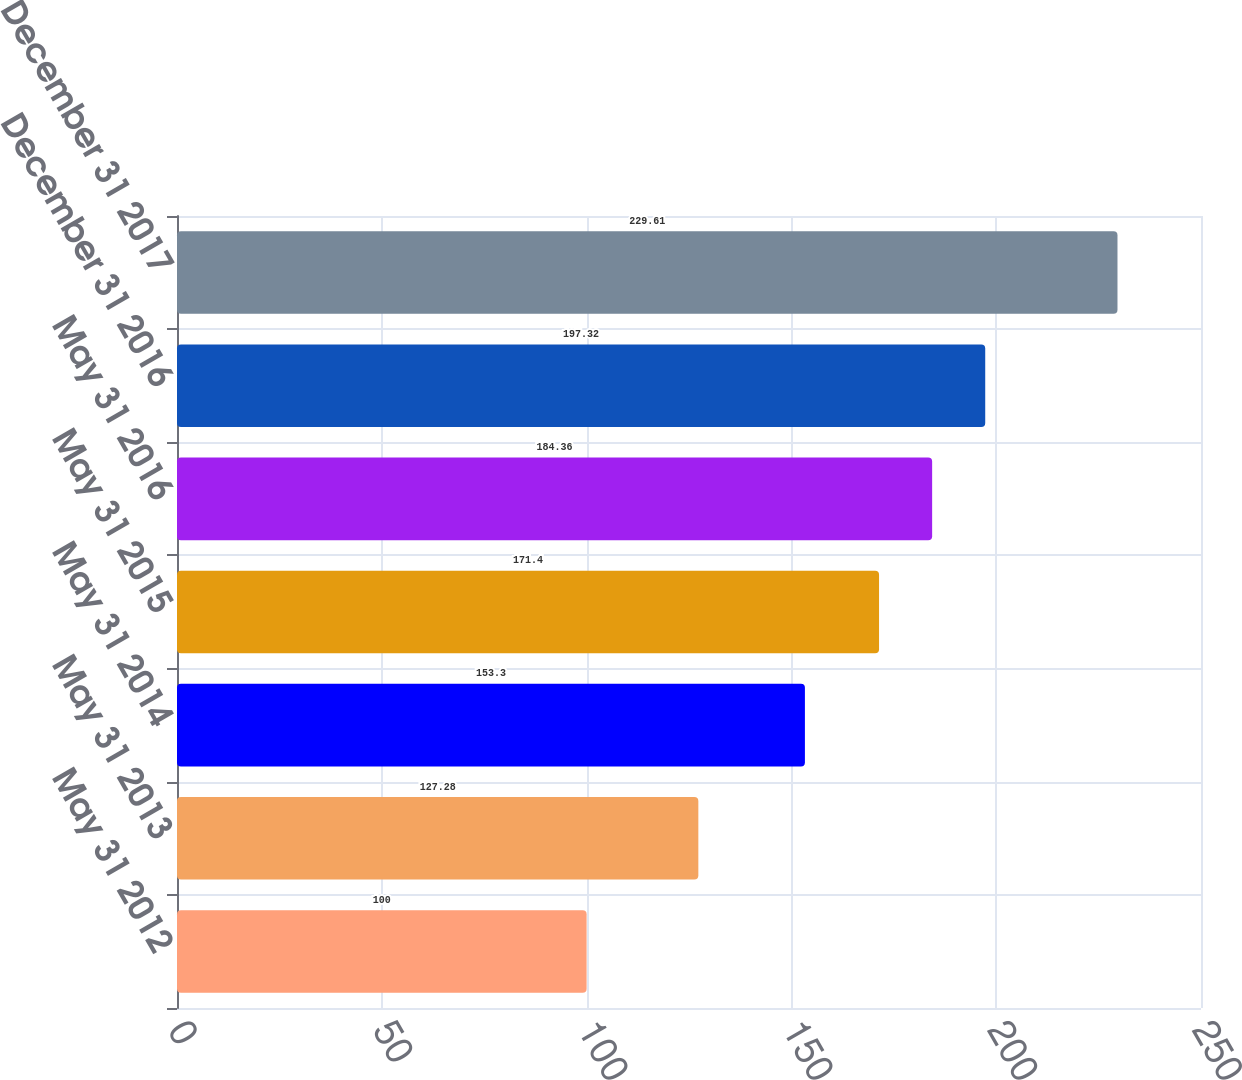<chart> <loc_0><loc_0><loc_500><loc_500><bar_chart><fcel>May 31 2012<fcel>May 31 2013<fcel>May 31 2014<fcel>May 31 2015<fcel>May 31 2016<fcel>December 31 2016<fcel>December 31 2017<nl><fcel>100<fcel>127.28<fcel>153.3<fcel>171.4<fcel>184.36<fcel>197.32<fcel>229.61<nl></chart> 